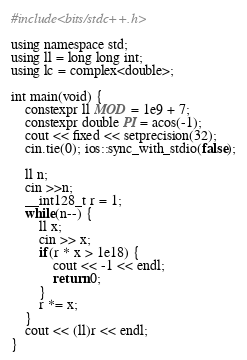Convert code to text. <code><loc_0><loc_0><loc_500><loc_500><_Ruby_>#include<bits/stdc++.h>

using namespace std;
using ll = long long int;
using lc = complex<double>;

int main(void) {
    constexpr ll MOD = 1e9 + 7;
    constexpr double PI = acos(-1);
    cout << fixed << setprecision(32);
    cin.tie(0); ios::sync_with_stdio(false);

    ll n;
    cin >>n;
    __int128_t r = 1;
    while(n--) {
        ll x;
        cin >> x;
        if(r * x > 1e18) {
            cout << -1 << endl;
            return 0;
        }
        r *= x;
    }
    cout << (ll)r << endl;
}
</code> 